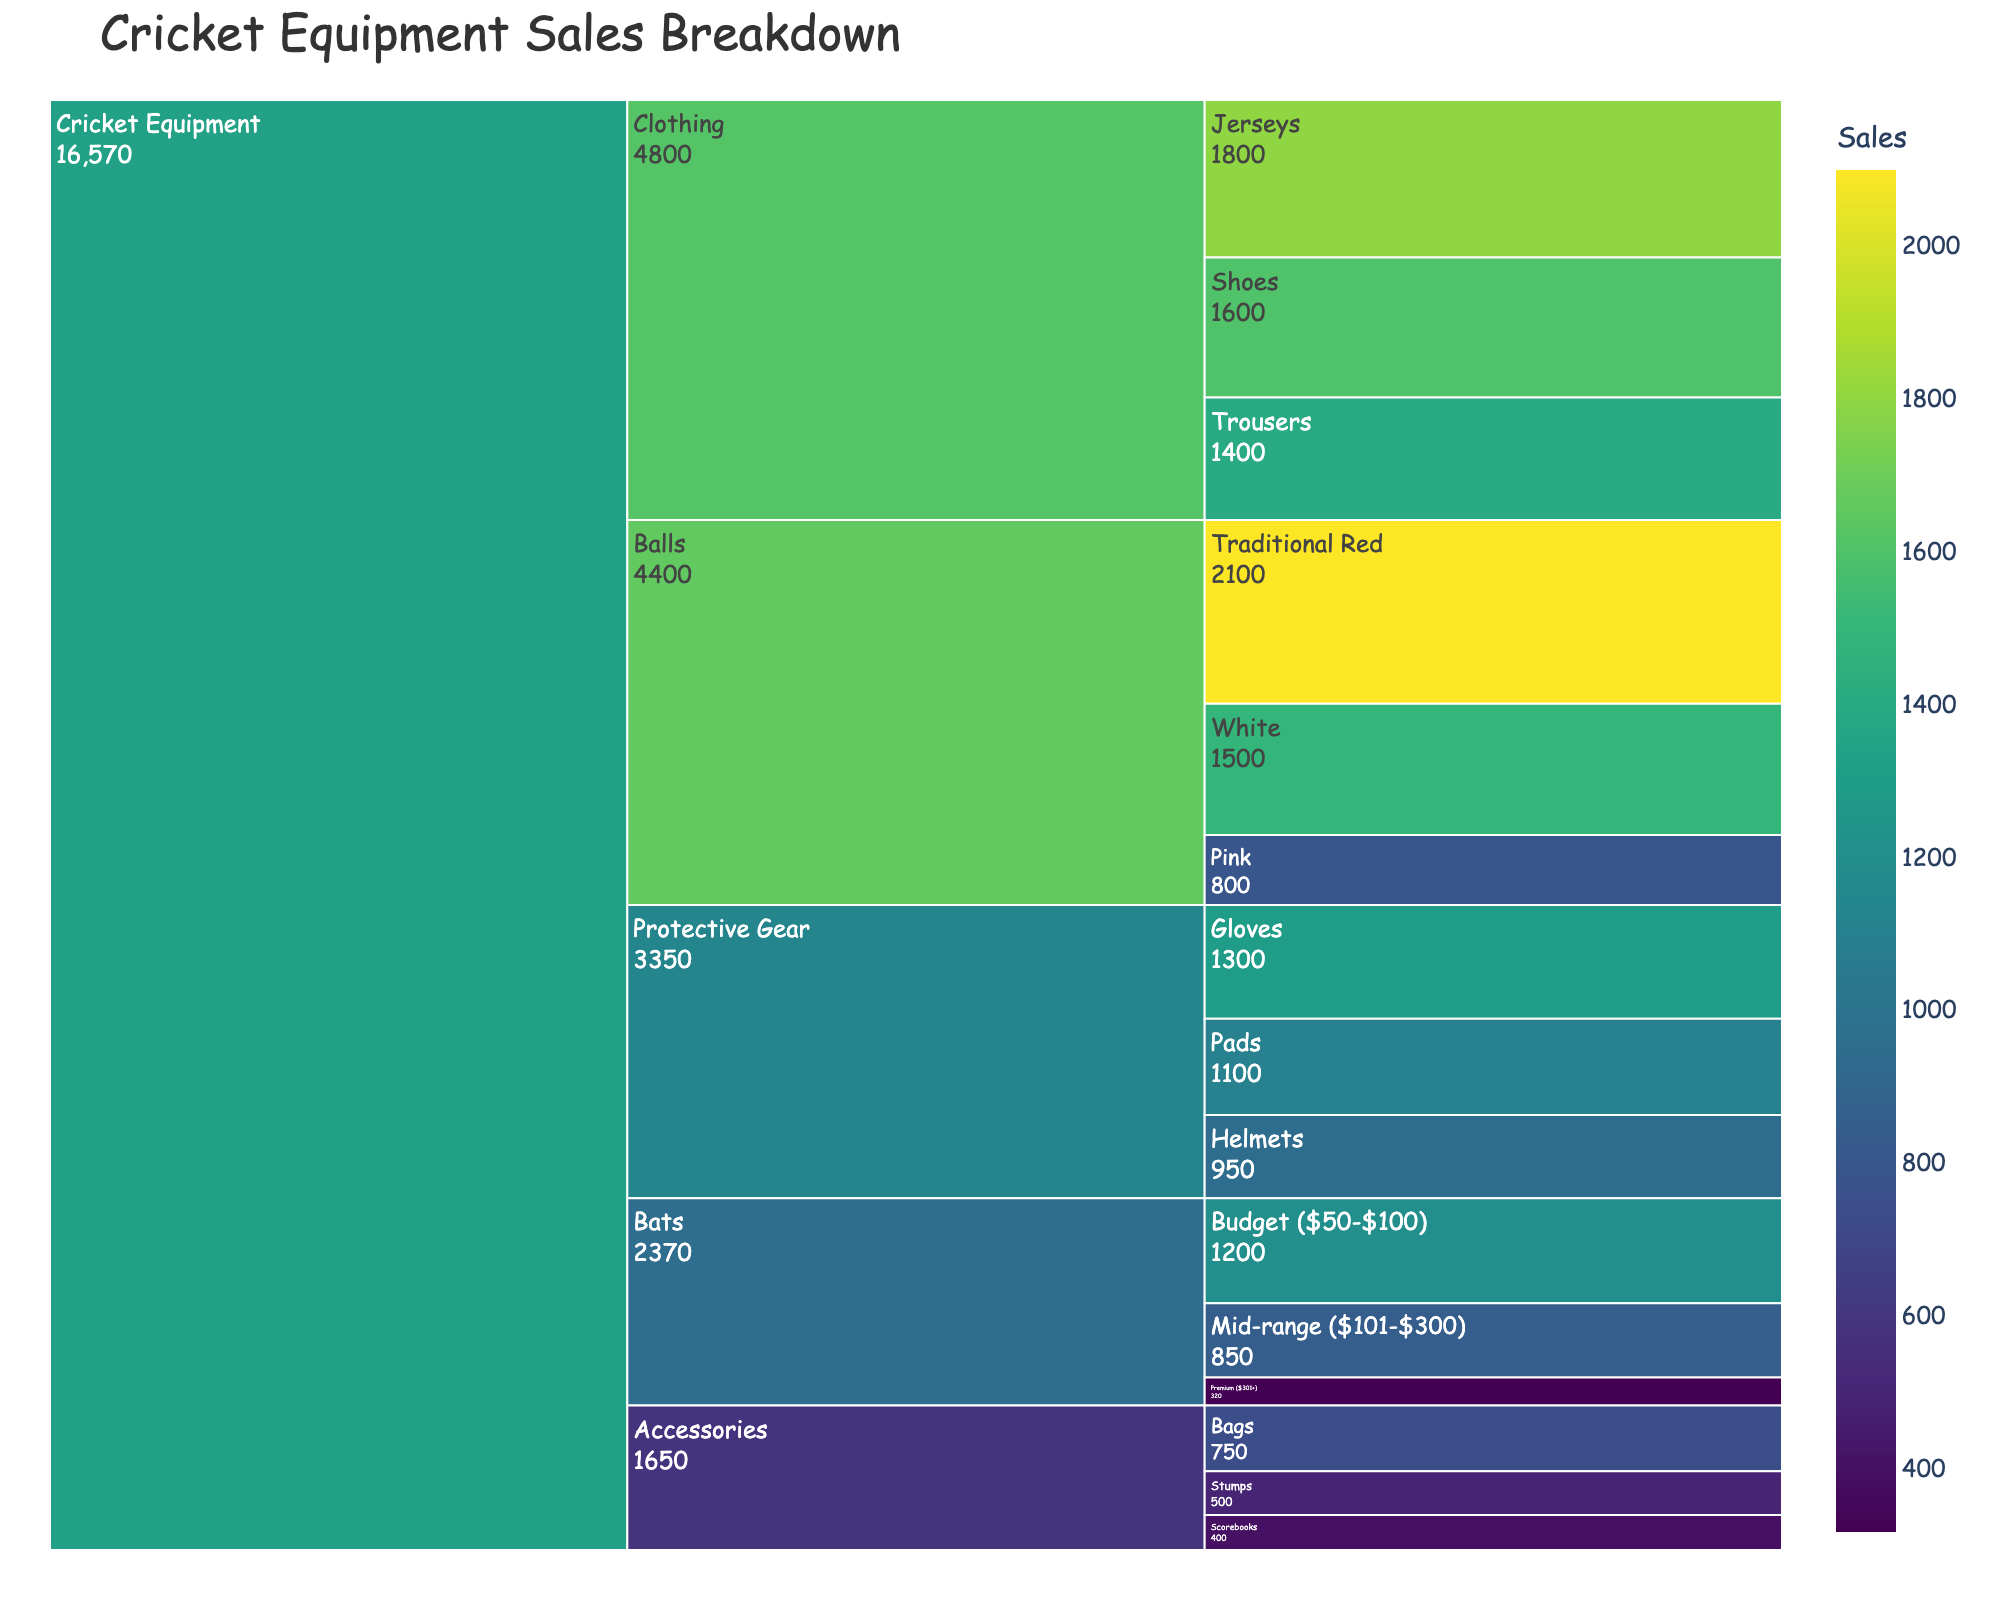What is the title of the figure? The title of the chart is clearly displayed at the top of the figure.
Answer: "Cricket Equipment Sales Breakdown" Which type of cricket balls has the highest sales? The icicle chart breaks down sales by type for each category, and by observing the sales figures, Traditional Red balls have the highest sales.
Answer: Traditional Red What is the total sales for Protective Gear? To get the total sales for Protective Gear, sum up the sales of Helmets, Gloves, and Pads (950 + 1300 + 1100).
Answer: 3350 Is the sales figure for Premium Bats greater than for Jersey sales? By comparing the sales figures of Premium Bats (320) and Jerseys (1800), it is clear that Jersey sales are higher.
Answer: No Which category has lower sales: Accessories or Balls? By comparing the sum of sales within each category, Accessories (750 + 500 + 400 = 1650) have lower sales than Balls (2100 + 1500 + 800 = 4400).
Answer: Accessories How do the sales of Mid-range Bats compare with White Balls? The sales of Mid-range Bats (850) are lower than those of White Balls (1500).
Answer: Lower What is the total sales for all types of Clothing? The total sales for Clothing is the sum of sales for Jerseys, Trousers, and Shoes (1800 + 1400 + 1600).
Answer: 4800 Which type of Protective Gear has the highest sales? Among Protective Gear, Gloves have the highest sales with a value of 1300.
Answer: Gloves How much higher are the sales of Traditional Red Balls compared to Pink Balls? The difference in sales between Traditional Red Balls (2100) and Pink Balls (800) is calculated as 2100 - 800.
Answer: 1300 Which category has the most diverse range of products? By observing the variety of product types listed, Accessories have the most diverse range with three different products (Bags, Stumps, Scorebooks).
Answer: Accessories 